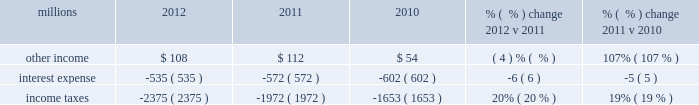Maintenance and contract expenses incurred by our subsidiaries for external transportation services ) ; materials used to maintain the railroad 2019s lines , structures , and equipment ; costs of operating facilities jointly used by uprr and other railroads ; transportation and lodging for train crew employees ; trucking and contracting costs for intermodal containers ; leased automobile maintenance expenses ; and tools and supplies .
Expenses for contract services increased $ 103 million in 2012 versus 2011 , primarily due to increased demand for transportation services purchased by our logistics subsidiaries for their customers and additional costs for repair and maintenance of locomotives and freight cars .
Expenses for contract services increased $ 106 million in 2011 versus 2010 , driven by volume-related external transportation services incurred by our subsidiaries , and various other types of contractual services , including flood-related repairs , mitigation and improvements .
Volume-related crew transportation and lodging costs , as well as expenses associated with jointly owned operating facilities , also increased costs compared to 2010 .
In addition , an increase in locomotive maintenance materials used to prepare a portion of our locomotive fleet for return to active service due to increased volume and additional capacity for weather related issues and warranty expirations increased expenses in 2011 .
Depreciation 2013 the majority of depreciation relates to road property , including rail , ties , ballast , and other track material .
A higher depreciable asset base , reflecting ongoing capital spending , increased depreciation expense in 2012 compared to 2011 .
A higher depreciable asset base , reflecting ongoing capital spending , increased depreciation expense in 2011 compared to 2010 .
Higher depreciation rates for rail and other track material also contributed to the increase .
The higher rates , which became effective january 1 , 2011 , resulted primarily from increased track usage ( based on higher gross ton-miles in 2010 ) .
Equipment and other rents 2013 equipment and other rents expense primarily includes rental expense that the railroad pays for freight cars owned by other railroads or private companies ; freight car , intermodal , and locomotive leases ; and office and other rent expenses .
Increased automotive and intermodal shipments , partially offset by improved car-cycle times , drove an increase in our short-term freight car rental expense in 2012 .
Conversely , lower locomotive lease expense partially offset the higher freight car rental expense .
Costs increased in 2011 versus 2010 as higher short-term freight car rental expense and container lease expense offset lower freight car and locomotive lease expense .
Other 2013 other expenses include personal injury , freight and property damage , destruction of equipment , insurance , environmental , bad debt , state and local taxes , utilities , telephone and cellular , employee travel , computer software , and other general expenses .
Other costs in 2012 were slightly higher than 2011 primarily due to higher property taxes .
Despite continual improvement in our safety experience and lower estimated annual costs , personal injury expense increased in 2012 compared to 2011 , as the liability reduction resulting from historical claim experience was less than the reduction in 2011 .
Higher property taxes , casualty costs associated with destroyed equipment , damaged freight and property and environmental costs increased other costs in 2011 compared to 2010 .
A one-time payment of $ 45 million in the first quarter of 2010 related to a transaction with csxi and continued improvement in our safety performance and lower estimated liability for personal injury , which reduced our personal injury expense year-over-year , partially offset increases in other costs .
Non-operating items millions 2012 2011 2010 % (  % ) change 2012 v 2011 % (  % ) change 2011 v 2010 .
Other income 2013 other income decreased in 2012 versus 2011 due to lower gains from real estate sales and higher environmental costs associated with non-operating properties , partially offset by an interest payment from a tax refund. .
Did contract services expense increase more in 2012 than in 2011? 
Computations: (103 > 106)
Answer: no. 